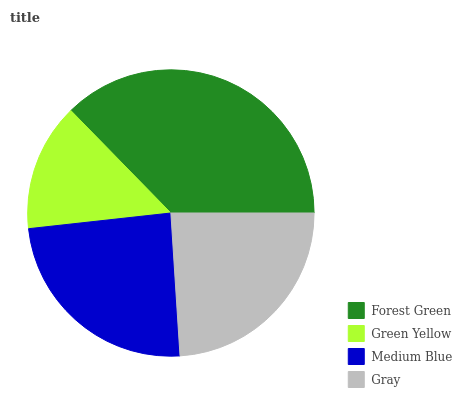Is Green Yellow the minimum?
Answer yes or no. Yes. Is Forest Green the maximum?
Answer yes or no. Yes. Is Medium Blue the minimum?
Answer yes or no. No. Is Medium Blue the maximum?
Answer yes or no. No. Is Medium Blue greater than Green Yellow?
Answer yes or no. Yes. Is Green Yellow less than Medium Blue?
Answer yes or no. Yes. Is Green Yellow greater than Medium Blue?
Answer yes or no. No. Is Medium Blue less than Green Yellow?
Answer yes or no. No. Is Medium Blue the high median?
Answer yes or no. Yes. Is Gray the low median?
Answer yes or no. Yes. Is Gray the high median?
Answer yes or no. No. Is Green Yellow the low median?
Answer yes or no. No. 